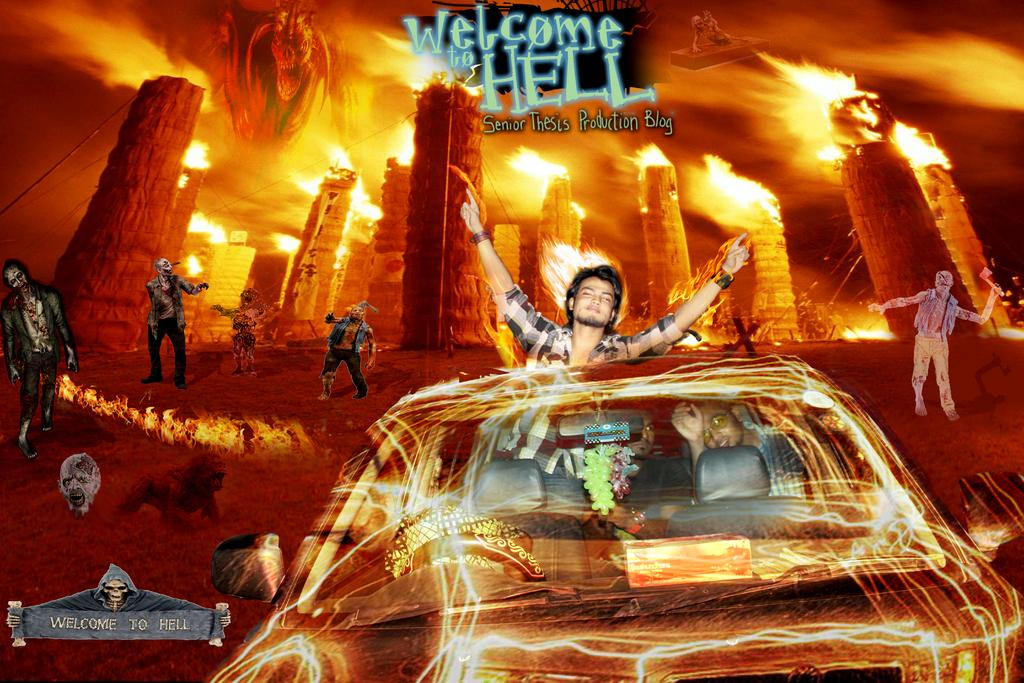Provide a one-sentence caption for the provided image. A poster of two guys driving through fire and the sign says Welcome to Hell. 